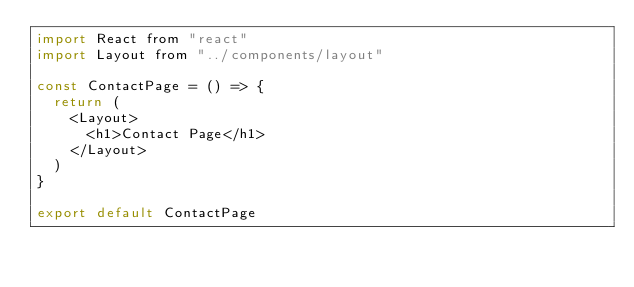<code> <loc_0><loc_0><loc_500><loc_500><_JavaScript_>import React from "react"
import Layout from "../components/layout"

const ContactPage = () => {
  return (
    <Layout>
      <h1>Contact Page</h1>
    </Layout>
  )
}

export default ContactPage
</code> 